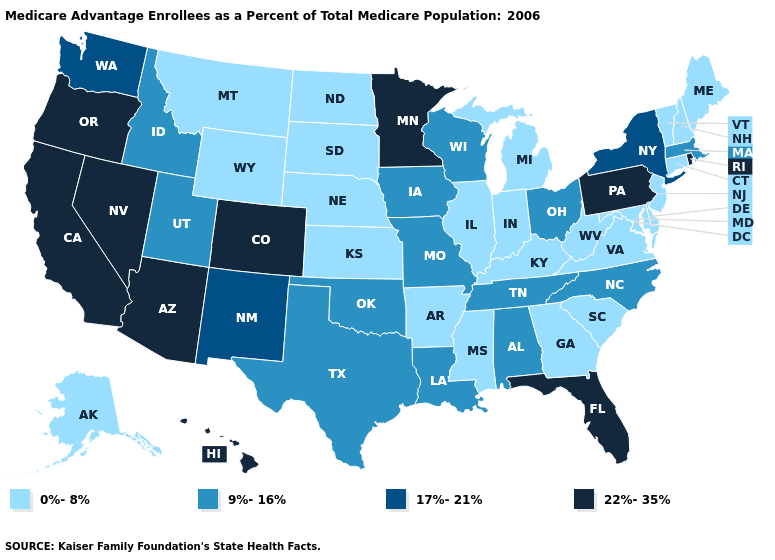Name the states that have a value in the range 9%-16%?
Write a very short answer. Alabama, Iowa, Idaho, Louisiana, Massachusetts, Missouri, North Carolina, Ohio, Oklahoma, Tennessee, Texas, Utah, Wisconsin. What is the value of Alaska?
Keep it brief. 0%-8%. What is the value of New York?
Keep it brief. 17%-21%. What is the highest value in the USA?
Answer briefly. 22%-35%. What is the value of Texas?
Quick response, please. 9%-16%. How many symbols are there in the legend?
Give a very brief answer. 4. Name the states that have a value in the range 0%-8%?
Concise answer only. Alaska, Arkansas, Connecticut, Delaware, Georgia, Illinois, Indiana, Kansas, Kentucky, Maryland, Maine, Michigan, Mississippi, Montana, North Dakota, Nebraska, New Hampshire, New Jersey, South Carolina, South Dakota, Virginia, Vermont, West Virginia, Wyoming. Does Ohio have a higher value than New Mexico?
Give a very brief answer. No. What is the value of Texas?
Concise answer only. 9%-16%. Among the states that border Connecticut , which have the highest value?
Write a very short answer. Rhode Island. Which states have the lowest value in the USA?
Concise answer only. Alaska, Arkansas, Connecticut, Delaware, Georgia, Illinois, Indiana, Kansas, Kentucky, Maryland, Maine, Michigan, Mississippi, Montana, North Dakota, Nebraska, New Hampshire, New Jersey, South Carolina, South Dakota, Virginia, Vermont, West Virginia, Wyoming. What is the value of West Virginia?
Give a very brief answer. 0%-8%. Among the states that border Maryland , which have the lowest value?
Give a very brief answer. Delaware, Virginia, West Virginia. Does North Dakota have the highest value in the MidWest?
Keep it brief. No. What is the lowest value in states that border Georgia?
Concise answer only. 0%-8%. 